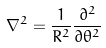<formula> <loc_0><loc_0><loc_500><loc_500>\nabla ^ { 2 } = \frac { 1 } { R ^ { 2 } } \frac { \partial ^ { 2 } } { \partial \theta ^ { 2 } }</formula> 